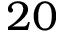<formula> <loc_0><loc_0><loc_500><loc_500>2 0</formula> 